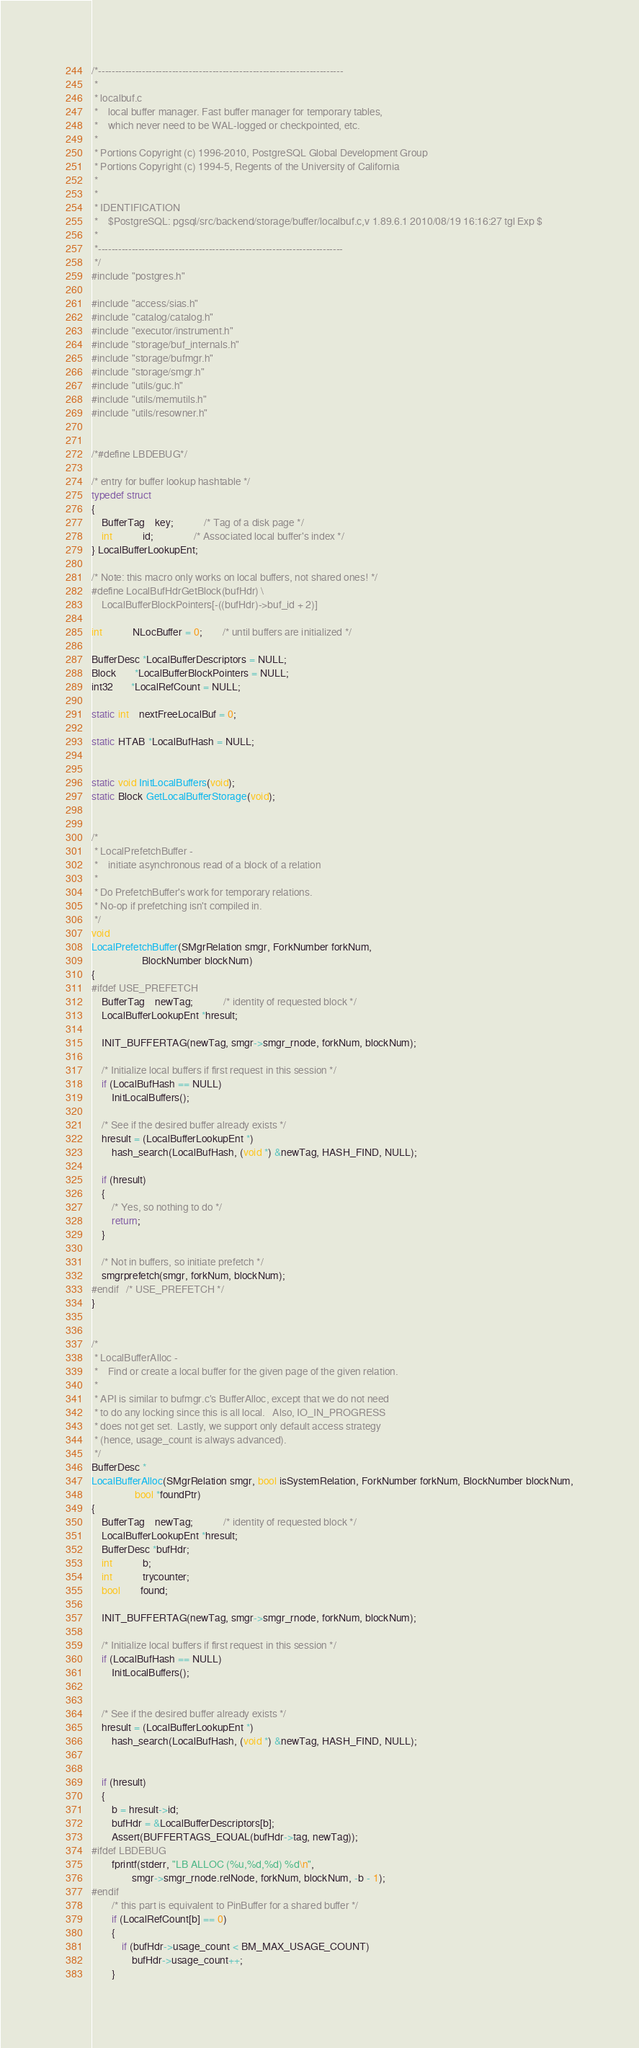<code> <loc_0><loc_0><loc_500><loc_500><_C_>/*-------------------------------------------------------------------------
 *
 * localbuf.c
 *	  local buffer manager. Fast buffer manager for temporary tables,
 *	  which never need to be WAL-logged or checkpointed, etc.
 *
 * Portions Copyright (c) 1996-2010, PostgreSQL Global Development Group
 * Portions Copyright (c) 1994-5, Regents of the University of California
 *
 *
 * IDENTIFICATION
 *	  $PostgreSQL: pgsql/src/backend/storage/buffer/localbuf.c,v 1.89.6.1 2010/08/19 16:16:27 tgl Exp $
 *
 *-------------------------------------------------------------------------
 */
#include "postgres.h"

#include "access/sias.h"
#include "catalog/catalog.h"
#include "executor/instrument.h"
#include "storage/buf_internals.h"
#include "storage/bufmgr.h"
#include "storage/smgr.h"
#include "utils/guc.h"
#include "utils/memutils.h"
#include "utils/resowner.h"


/*#define LBDEBUG*/

/* entry for buffer lookup hashtable */
typedef struct
{
	BufferTag	key;			/* Tag of a disk page */
	int			id;				/* Associated local buffer's index */
} LocalBufferLookupEnt;

/* Note: this macro only works on local buffers, not shared ones! */
#define LocalBufHdrGetBlock(bufHdr) \
	LocalBufferBlockPointers[-((bufHdr)->buf_id + 2)]

int			NLocBuffer = 0;		/* until buffers are initialized */

BufferDesc *LocalBufferDescriptors = NULL;
Block	   *LocalBufferBlockPointers = NULL;
int32	   *LocalRefCount = NULL;

static int	nextFreeLocalBuf = 0;

static HTAB *LocalBufHash = NULL;


static void InitLocalBuffers(void);
static Block GetLocalBufferStorage(void);


/*
 * LocalPrefetchBuffer -
 *	  initiate asynchronous read of a block of a relation
 *
 * Do PrefetchBuffer's work for temporary relations.
 * No-op if prefetching isn't compiled in.
 */
void
LocalPrefetchBuffer(SMgrRelation smgr, ForkNumber forkNum,
					BlockNumber blockNum)
{
#ifdef USE_PREFETCH
	BufferTag	newTag;			/* identity of requested block */
	LocalBufferLookupEnt *hresult;

	INIT_BUFFERTAG(newTag, smgr->smgr_rnode, forkNum, blockNum);

	/* Initialize local buffers if first request in this session */
	if (LocalBufHash == NULL)
		InitLocalBuffers();

	/* See if the desired buffer already exists */
	hresult = (LocalBufferLookupEnt *)
		hash_search(LocalBufHash, (void *) &newTag, HASH_FIND, NULL);

	if (hresult)
	{
		/* Yes, so nothing to do */
		return;
	}

	/* Not in buffers, so initiate prefetch */
	smgrprefetch(smgr, forkNum, blockNum);
#endif   /* USE_PREFETCH */
}


/*
 * LocalBufferAlloc -
 *	  Find or create a local buffer for the given page of the given relation.
 *
 * API is similar to bufmgr.c's BufferAlloc, except that we do not need
 * to do any locking since this is all local.	Also, IO_IN_PROGRESS
 * does not get set.  Lastly, we support only default access strategy
 * (hence, usage_count is always advanced).
 */
BufferDesc *
LocalBufferAlloc(SMgrRelation smgr, bool isSystemRelation, ForkNumber forkNum, BlockNumber blockNum,
				 bool *foundPtr)
{
	BufferTag	newTag;			/* identity of requested block */
	LocalBufferLookupEnt *hresult;
	BufferDesc *bufHdr;
	int			b;
	int			trycounter;
	bool		found;

	INIT_BUFFERTAG(newTag, smgr->smgr_rnode, forkNum, blockNum);

	/* Initialize local buffers if first request in this session */
	if (LocalBufHash == NULL)
		InitLocalBuffers();


	/* See if the desired buffer already exists */
	hresult = (LocalBufferLookupEnt *)
		hash_search(LocalBufHash, (void *) &newTag, HASH_FIND, NULL);


	if (hresult)
	{
		b = hresult->id;
		bufHdr = &LocalBufferDescriptors[b];
		Assert(BUFFERTAGS_EQUAL(bufHdr->tag, newTag));
#ifdef LBDEBUG
		fprintf(stderr, "LB ALLOC (%u,%d,%d) %d\n",
				smgr->smgr_rnode.relNode, forkNum, blockNum, -b - 1);
#endif
		/* this part is equivalent to PinBuffer for a shared buffer */
		if (LocalRefCount[b] == 0)
		{
			if (bufHdr->usage_count < BM_MAX_USAGE_COUNT)
				bufHdr->usage_count++;
		}</code> 